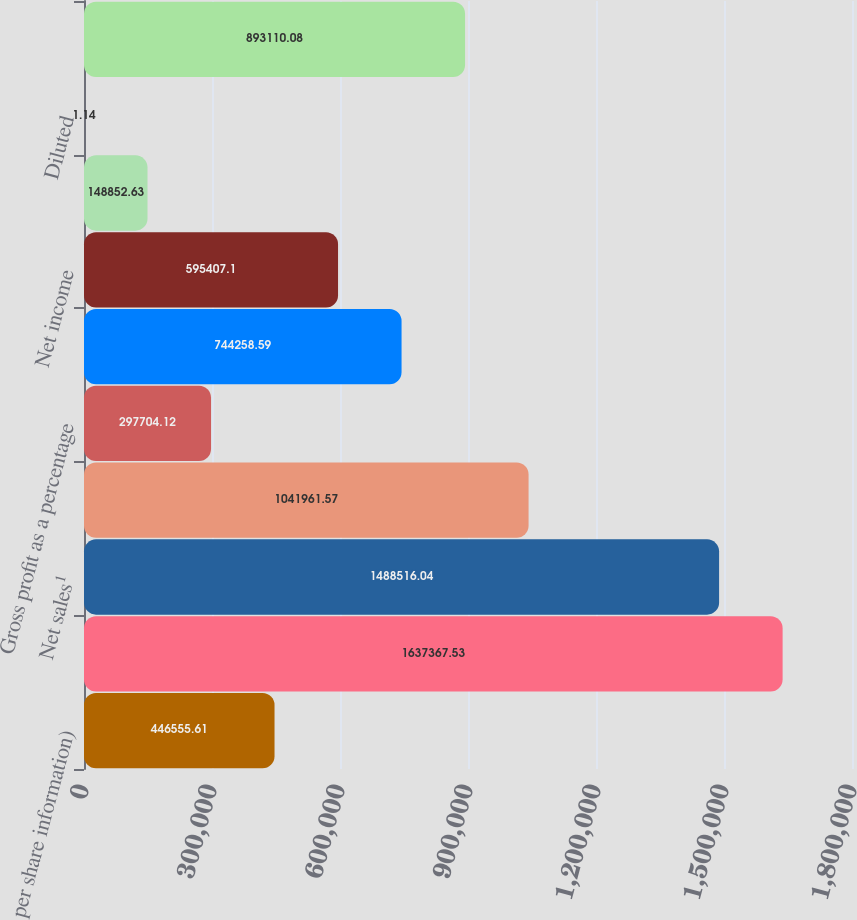Convert chart. <chart><loc_0><loc_0><loc_500><loc_500><bar_chart><fcel>per share information)<fcel>Gross sales¹<fcel>Net sales¹<fcel>Gross profit¹<fcel>Gross profit as a percentage<fcel>Operating income ²<fcel>Net income<fcel>Basic<fcel>Diluted<fcel>Cash cash equivalents and<nl><fcel>446556<fcel>1.63737e+06<fcel>1.48852e+06<fcel>1.04196e+06<fcel>297704<fcel>744259<fcel>595407<fcel>148853<fcel>1.14<fcel>893110<nl></chart> 